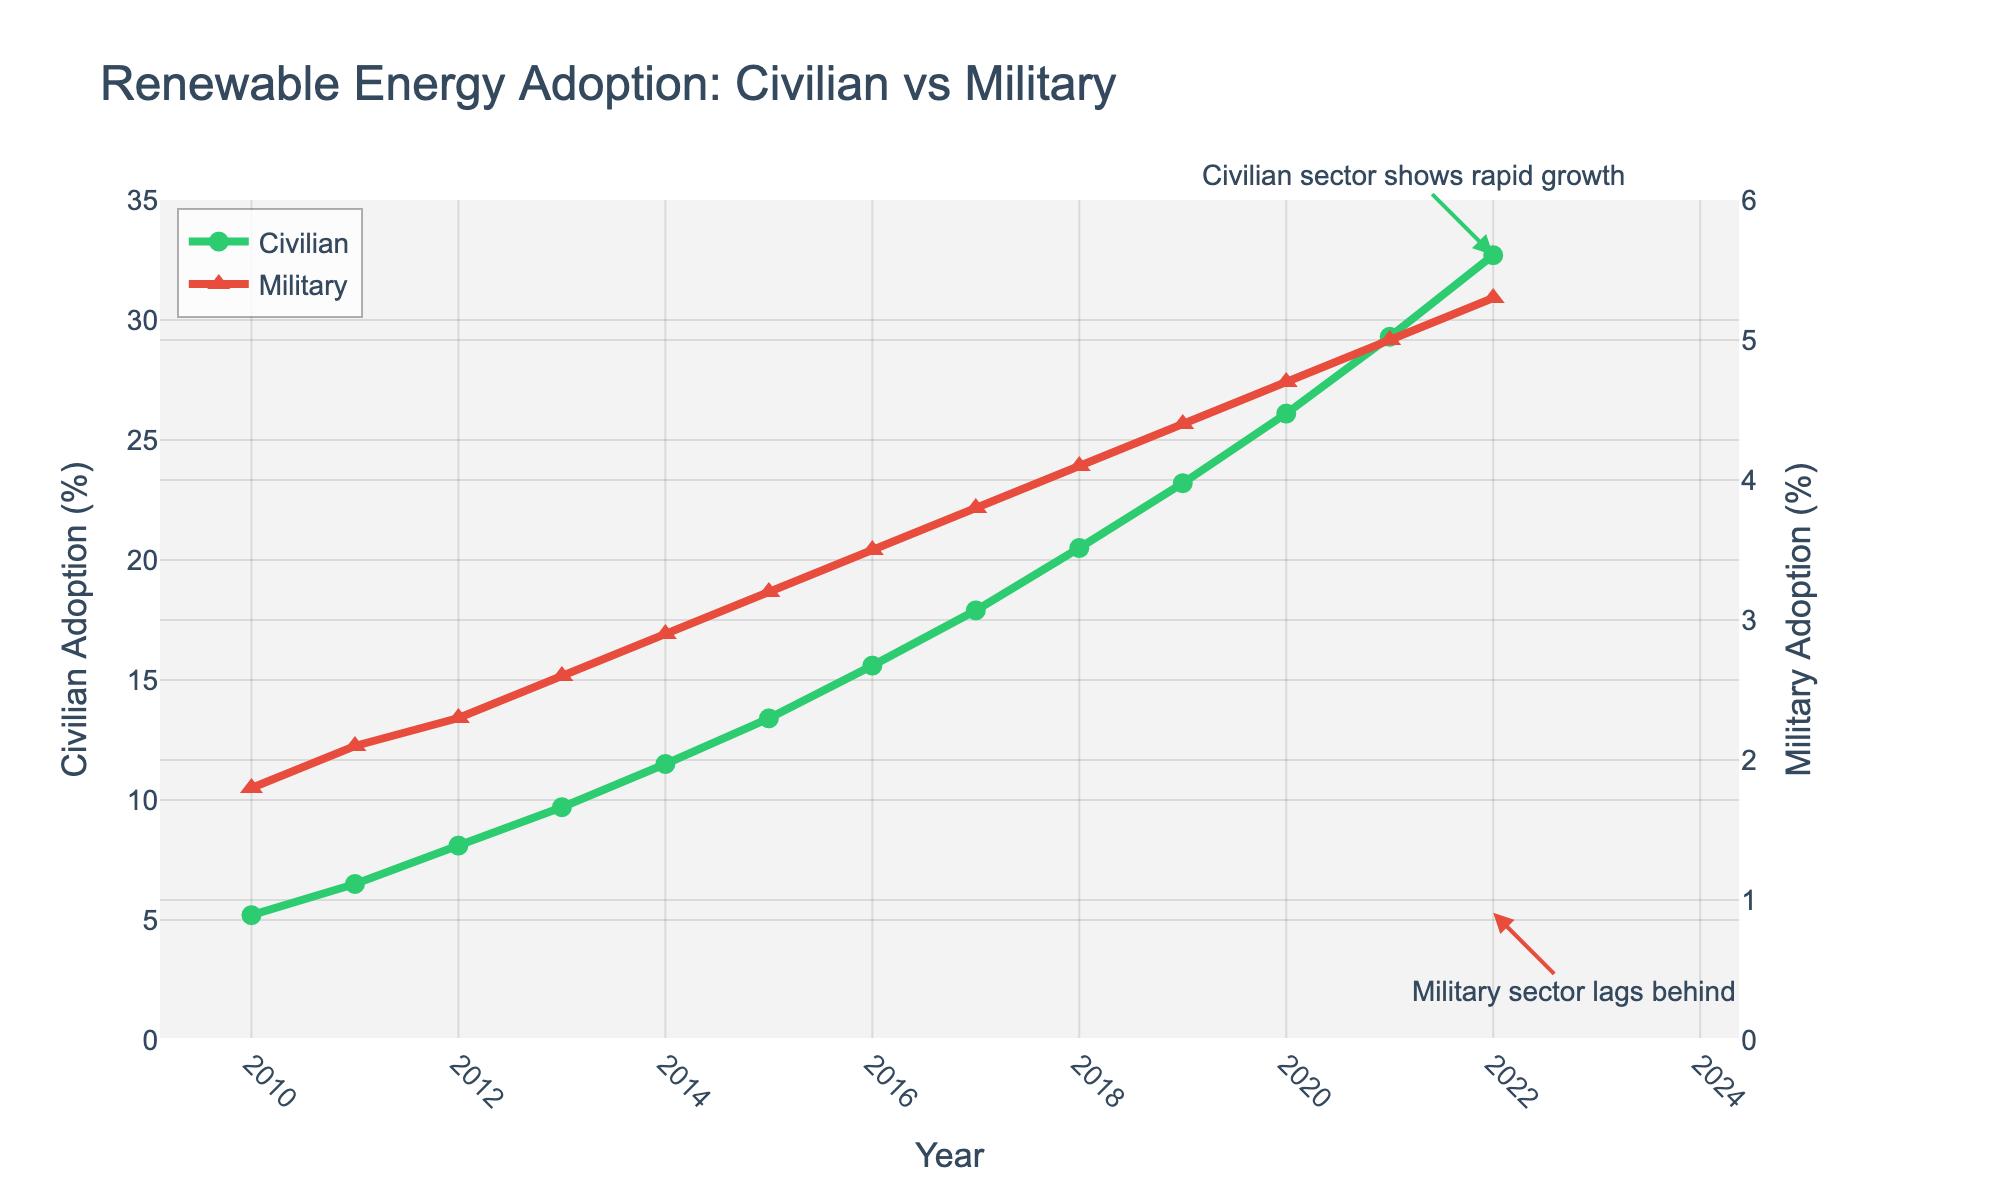Which year showed the biggest increase in civilian renewable adoption? To determine the year of the biggest increase in civilian renewable adoption, examine the increase from year to year: (6.5 - 5.2 = 1.3), (8.1 - 6.5 = 1.6), (9.7 - 8.1 = 1.6), (11.5 - 9.7 = 1.8), (13.4 - 11.5 = 1.9), (15.6 - 13.4 = 2.2), (17.9 - 15.6 = 2.3), (20.5 - 17.9 = 2.6), (23.2 - 20.5 = 2.7), (26.1 - 23.2 = 2.9), (29.3 - 26.1 = 3.2), (32.7 - 29.3 = 3.4). The year 2022 has the highest increase.
Answer: 2022 What is the percentage difference in renewable adoption between the civilian and military sectors in 2022? Subtract the military adoption percentage from the civilian adoption in 2022: 32.7 - 5.3 = 27.4.
Answer: 27.4 By how much did the military sector's renewable adoption rate increase from 2010 to 2022? Subtract the military adoption rate in 2010 from the rate in 2022: 5.3 - 1.8 = 3.5.
Answer: 3.5 How much did the civilian renewable adoption rate increase on average per year from 2010 to 2022? Calculate the total increase and then divide by the number of years: (32.7 - 5.2) / (2022 - 2010) = 27.5 / 12 = 2.2917.
Answer: 2.2917 Which sector shows a higher renewal energy adoption at every year from 2010 to 2022? By observing the plot, the green line (civilian sector) is consistently above the red line (military sector) across all years from 2010 to 2022.
Answer: Civilian What is the trend visible in the military sector's renewable adoption rate between 2010 and 2022? The military sector (red line) shows a consistent year-to-year increase over the time period as observed in the gradual upward trend.
Answer: Increasing In which year did the civilian sector reach 10% renewable adoption? By looking at the green line, the year when the civilian renewable adoption exceeded 10% was 2014, at 11.5%.
Answer: 2014 What's the combined adoption rate for civilian and military sectors in 2015? Add the adoption rates for both sectors in 2015: 13.4 (civilian) + 3.2 (military) = 16.6.
Answer: 16.6 Which year has the smallest difference in renewable adoption between civilian and military sectors? By comparing the differences, observe that the smallest difference (0.3%) occurred in 2010, with civilian adoption at 5.2% and military at 1.8%.
Answer: 2010 How much larger is the civilian renewable adoption rate than the military rate in 2020? Compute the difference for 2020: 26.1 (civilian) - 4.7 (military) = 21.4.
Answer: 21.4 